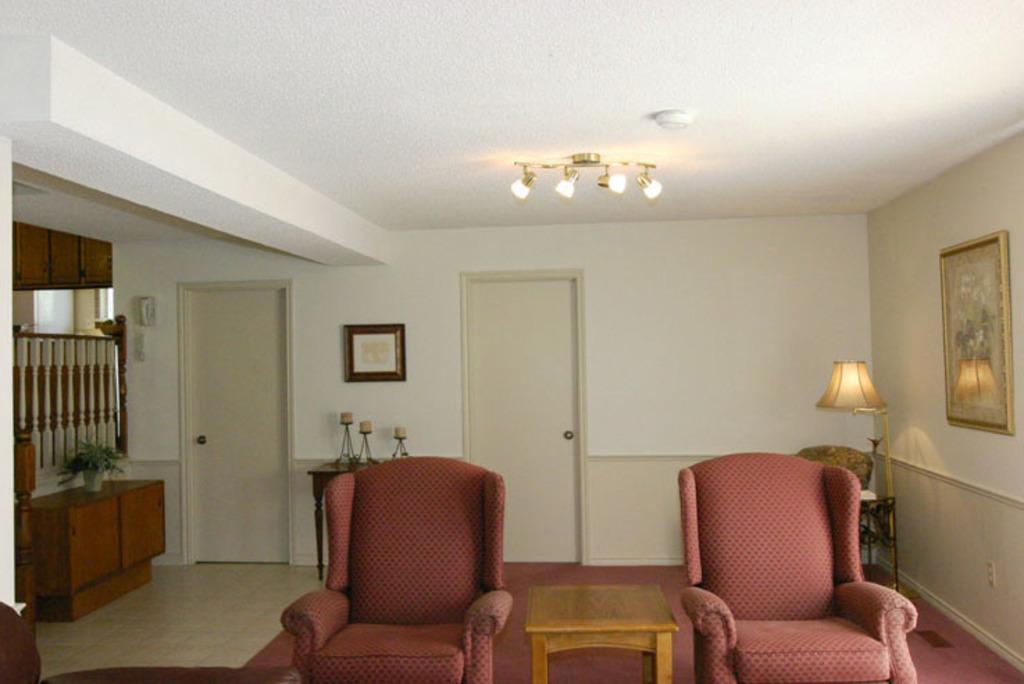What type of space is depicted in the image? The image shows a room. What type of furniture is present in the room? There is a chair and a stool in the room. What can be seen in the background of the room? There is a door, a lamp, and photo art in the background of the room. What type of jewel is hanging from the ceiling in the image? There is no jewel hanging from the ceiling in the image; it only shows a room with a chair, a stool, a door, a lamp, and photo art in the background. 